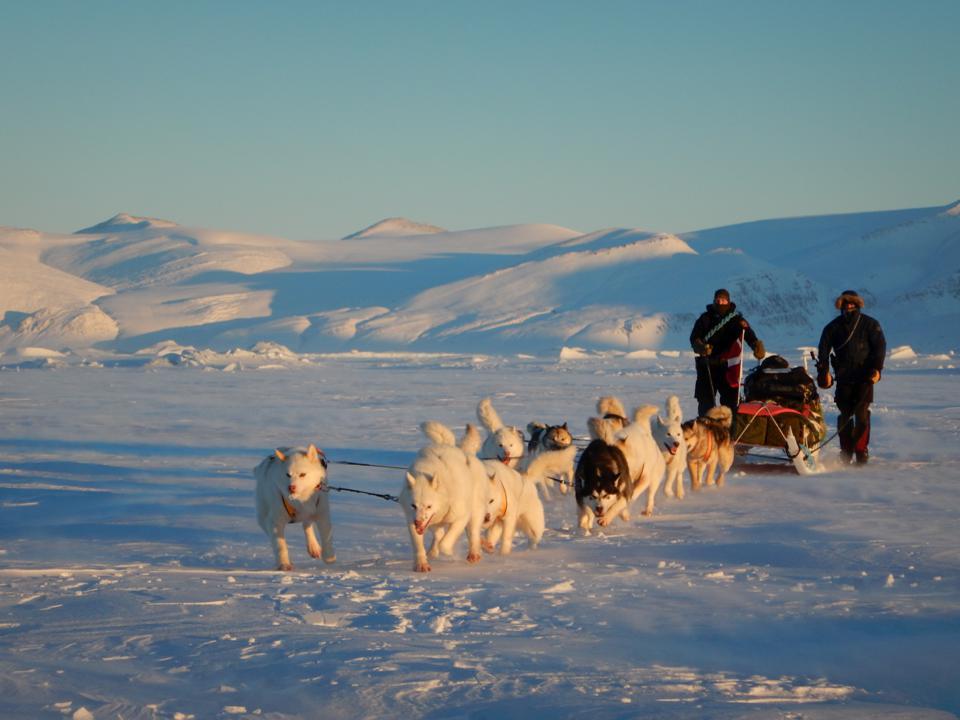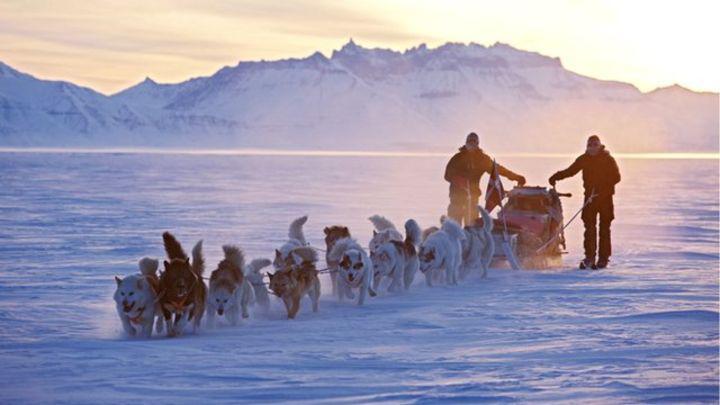The first image is the image on the left, the second image is the image on the right. Examine the images to the left and right. Is the description "Neither image shows a team of animals that are moving across the ground, and both images show sled dog teams." accurate? Answer yes or no. No. The first image is the image on the left, the second image is the image on the right. Analyze the images presented: Is the assertion "There are sled dogs laying in the snow." valid? Answer yes or no. No. 